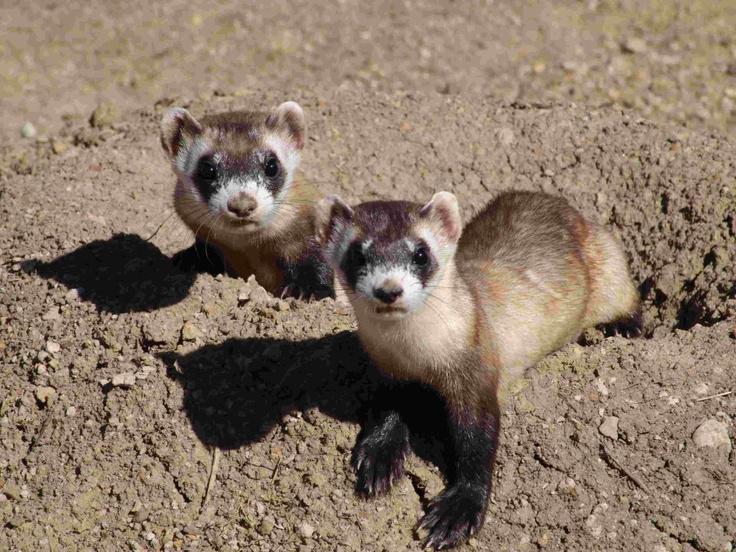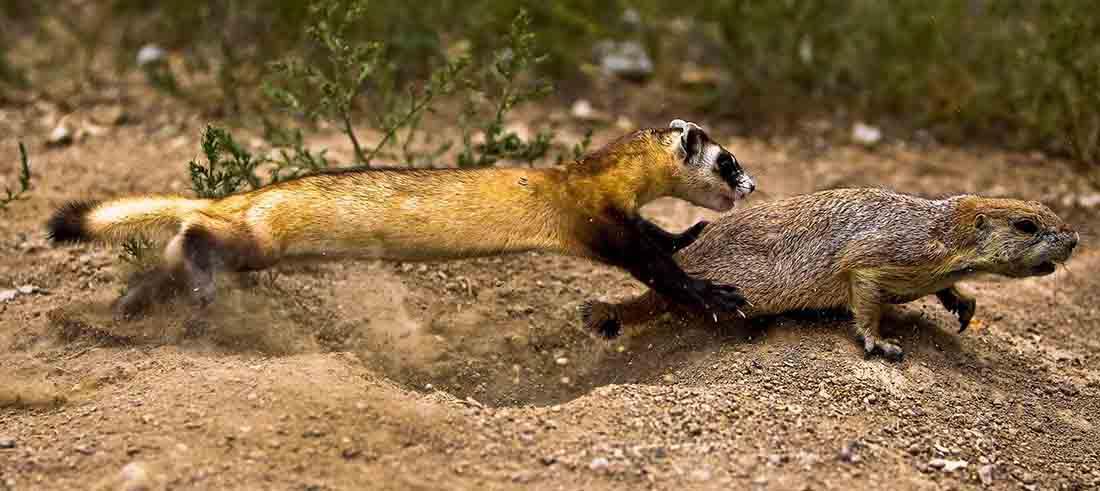The first image is the image on the left, the second image is the image on the right. For the images displayed, is the sentence "Both images contain a prairie dog partially submerged in a hole in the ground." factually correct? Answer yes or no. No. The first image is the image on the left, the second image is the image on the right. Analyze the images presented: Is the assertion "Each image shows exactly one ferret emerging from a hole in the ground." valid? Answer yes or no. No. 